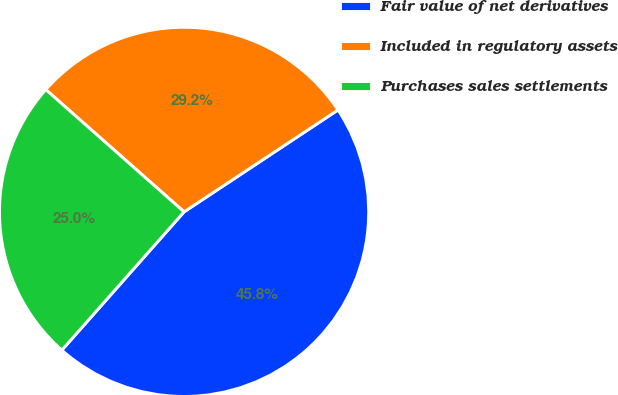Convert chart to OTSL. <chart><loc_0><loc_0><loc_500><loc_500><pie_chart><fcel>Fair value of net derivatives<fcel>Included in regulatory assets<fcel>Purchases sales settlements<nl><fcel>45.83%<fcel>29.17%<fcel>25.0%<nl></chart> 